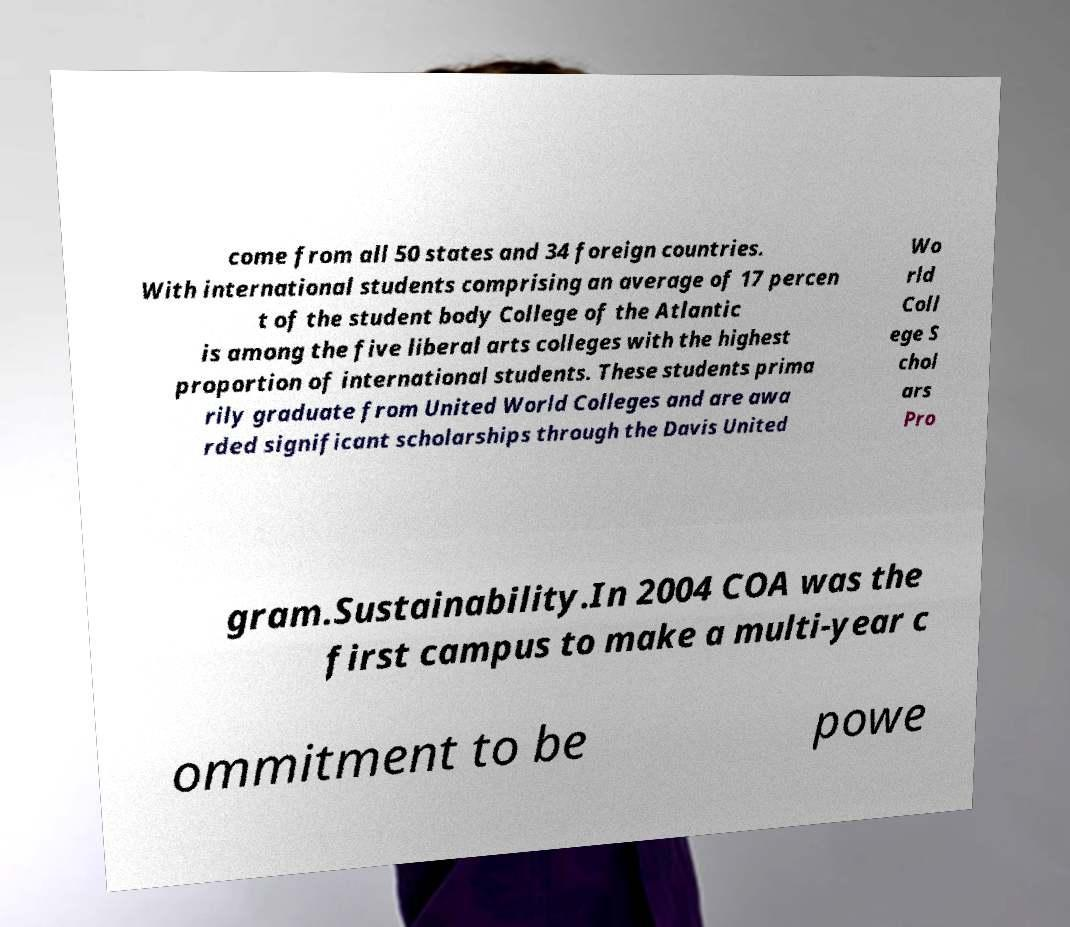Please read and relay the text visible in this image. What does it say? come from all 50 states and 34 foreign countries. With international students comprising an average of 17 percen t of the student body College of the Atlantic is among the five liberal arts colleges with the highest proportion of international students. These students prima rily graduate from United World Colleges and are awa rded significant scholarships through the Davis United Wo rld Coll ege S chol ars Pro gram.Sustainability.In 2004 COA was the first campus to make a multi-year c ommitment to be powe 